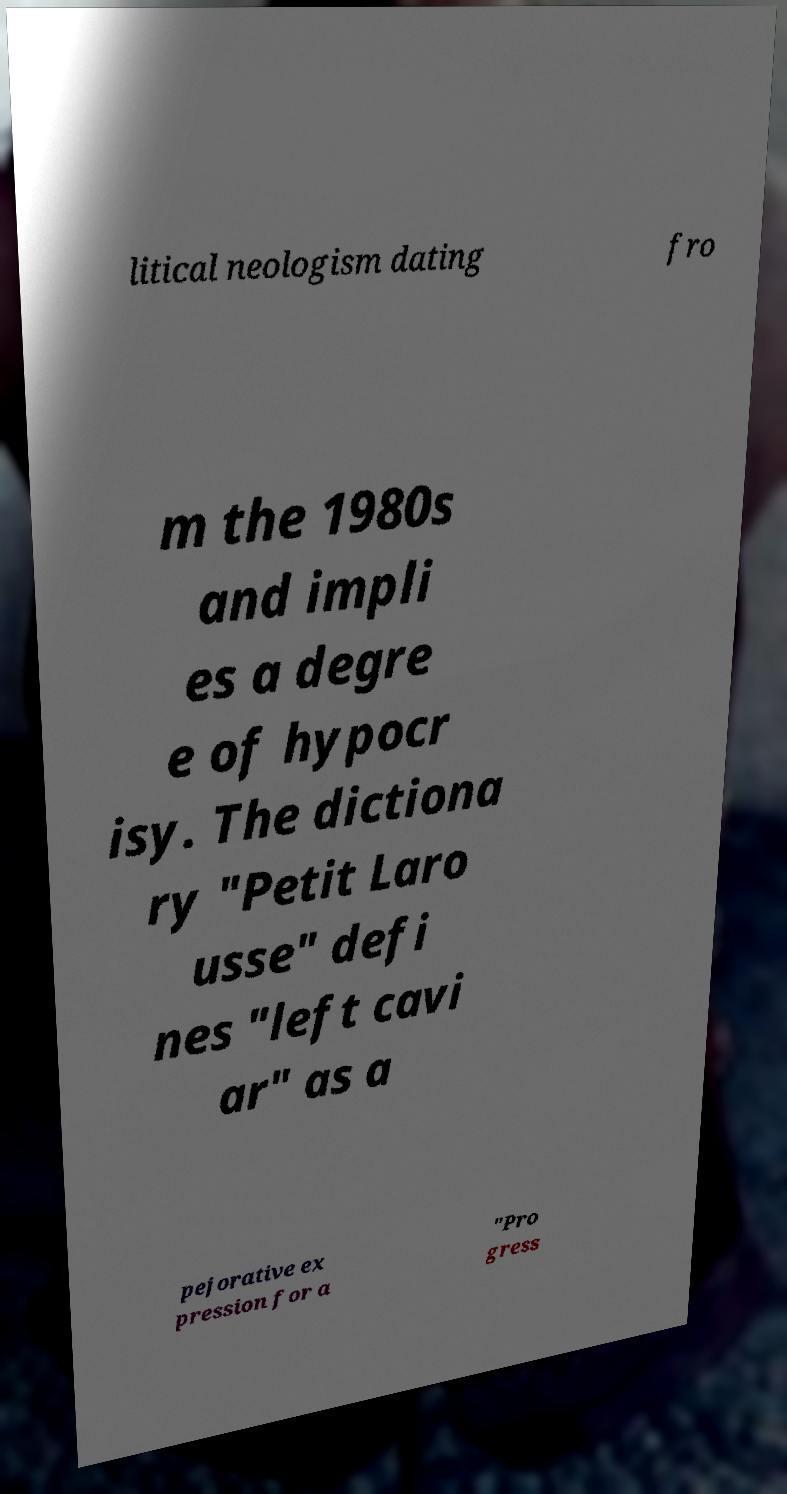I need the written content from this picture converted into text. Can you do that? litical neologism dating fro m the 1980s and impli es a degre e of hypocr isy. The dictiona ry "Petit Laro usse" defi nes "left cavi ar" as a pejorative ex pression for a "Pro gress 